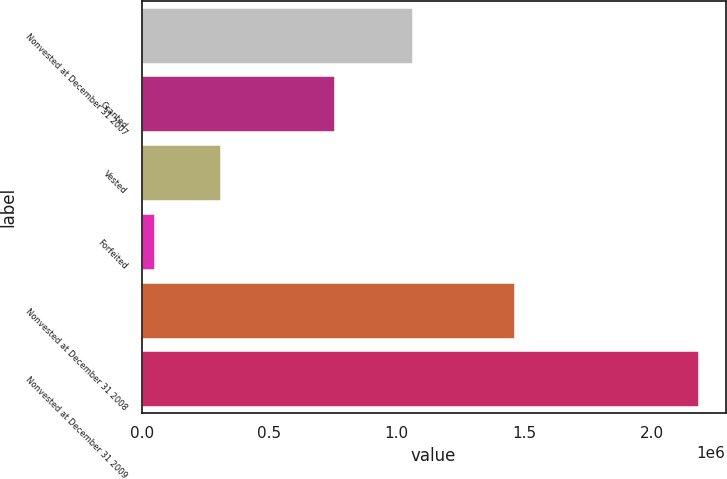Convert chart to OTSL. <chart><loc_0><loc_0><loc_500><loc_500><bar_chart><fcel>Nonvested at December 31 2007<fcel>Granted<fcel>Vested<fcel>Forfeited<fcel>Nonvested at December 31 2008<fcel>Nonvested at December 31 2009<nl><fcel>1.061e+06<fcel>755535<fcel>307905<fcel>48136<fcel>1.4605e+06<fcel>2.18124e+06<nl></chart> 